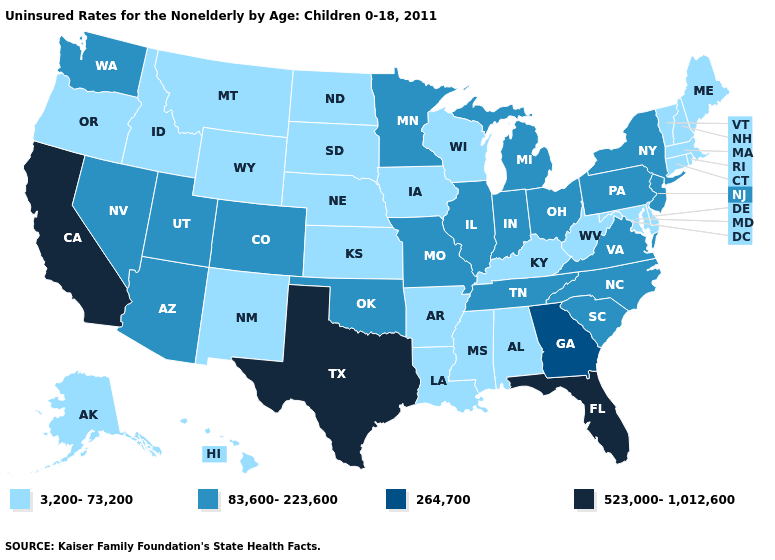Is the legend a continuous bar?
Quick response, please. No. Name the states that have a value in the range 83,600-223,600?
Keep it brief. Arizona, Colorado, Illinois, Indiana, Michigan, Minnesota, Missouri, Nevada, New Jersey, New York, North Carolina, Ohio, Oklahoma, Pennsylvania, South Carolina, Tennessee, Utah, Virginia, Washington. What is the value of West Virginia?
Short answer required. 3,200-73,200. Among the states that border Maryland , does Delaware have the lowest value?
Write a very short answer. Yes. What is the value of Ohio?
Write a very short answer. 83,600-223,600. What is the value of Missouri?
Be succinct. 83,600-223,600. What is the value of Arizona?
Quick response, please. 83,600-223,600. What is the lowest value in the USA?
Be succinct. 3,200-73,200. What is the lowest value in the USA?
Give a very brief answer. 3,200-73,200. Which states have the lowest value in the USA?
Write a very short answer. Alabama, Alaska, Arkansas, Connecticut, Delaware, Hawaii, Idaho, Iowa, Kansas, Kentucky, Louisiana, Maine, Maryland, Massachusetts, Mississippi, Montana, Nebraska, New Hampshire, New Mexico, North Dakota, Oregon, Rhode Island, South Dakota, Vermont, West Virginia, Wisconsin, Wyoming. What is the value of Alaska?
Concise answer only. 3,200-73,200. Among the states that border Ohio , does Michigan have the highest value?
Concise answer only. Yes. What is the highest value in states that border Missouri?
Write a very short answer. 83,600-223,600. Among the states that border Illinois , does Indiana have the highest value?
Concise answer only. Yes. What is the value of Hawaii?
Write a very short answer. 3,200-73,200. 